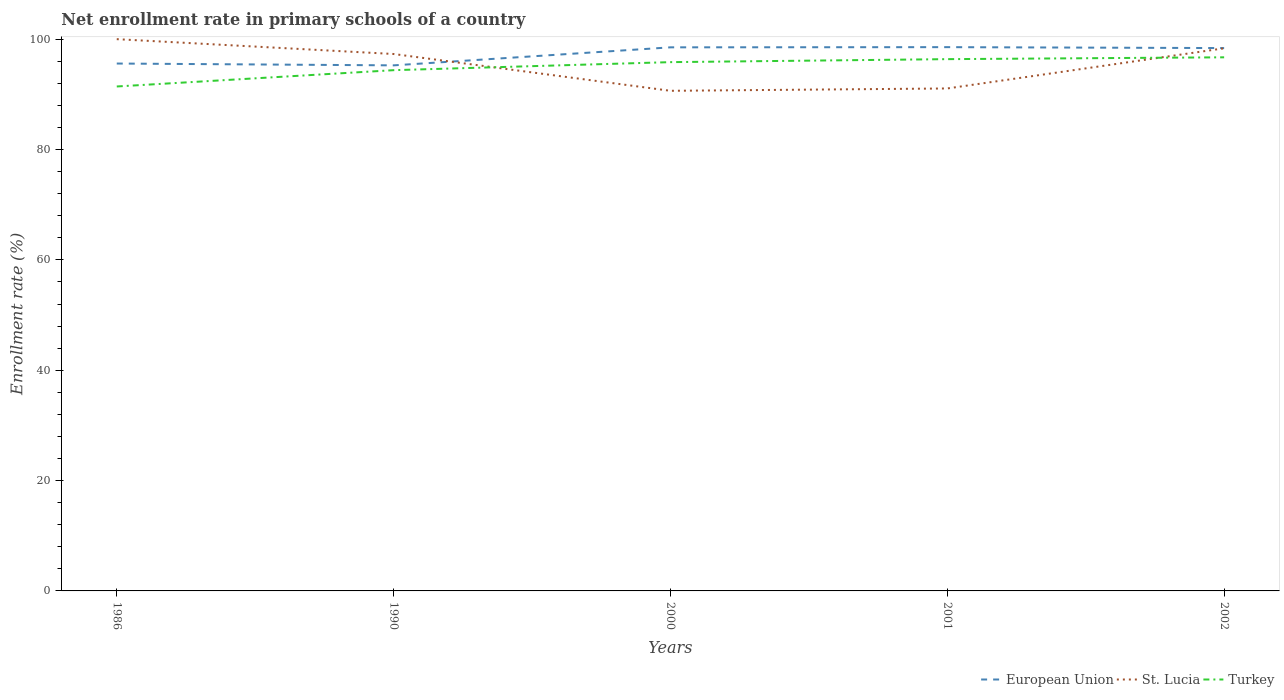Does the line corresponding to Turkey intersect with the line corresponding to St. Lucia?
Ensure brevity in your answer.  Yes. Is the number of lines equal to the number of legend labels?
Your answer should be compact. Yes. Across all years, what is the maximum enrollment rate in primary schools in European Union?
Give a very brief answer. 95.25. What is the total enrollment rate in primary schools in European Union in the graph?
Your answer should be compact. -2.8. What is the difference between the highest and the second highest enrollment rate in primary schools in Turkey?
Your response must be concise. 5.29. Is the enrollment rate in primary schools in St. Lucia strictly greater than the enrollment rate in primary schools in European Union over the years?
Give a very brief answer. No. How many years are there in the graph?
Provide a succinct answer. 5. What is the difference between two consecutive major ticks on the Y-axis?
Keep it short and to the point. 20. Does the graph contain any zero values?
Offer a terse response. No. Does the graph contain grids?
Ensure brevity in your answer.  No. How many legend labels are there?
Offer a terse response. 3. What is the title of the graph?
Give a very brief answer. Net enrollment rate in primary schools of a country. What is the label or title of the Y-axis?
Provide a short and direct response. Enrollment rate (%). What is the Enrollment rate (%) in European Union in 1986?
Give a very brief answer. 95.58. What is the Enrollment rate (%) in Turkey in 1986?
Offer a terse response. 91.42. What is the Enrollment rate (%) in European Union in 1990?
Ensure brevity in your answer.  95.25. What is the Enrollment rate (%) of St. Lucia in 1990?
Offer a terse response. 97.31. What is the Enrollment rate (%) of Turkey in 1990?
Provide a short and direct response. 94.38. What is the Enrollment rate (%) of European Union in 2000?
Keep it short and to the point. 98.52. What is the Enrollment rate (%) of St. Lucia in 2000?
Your answer should be very brief. 90.64. What is the Enrollment rate (%) in Turkey in 2000?
Give a very brief answer. 95.84. What is the Enrollment rate (%) of European Union in 2001?
Your answer should be compact. 98.55. What is the Enrollment rate (%) of St. Lucia in 2001?
Your answer should be very brief. 91.06. What is the Enrollment rate (%) in Turkey in 2001?
Ensure brevity in your answer.  96.38. What is the Enrollment rate (%) of European Union in 2002?
Provide a short and direct response. 98.38. What is the Enrollment rate (%) in St. Lucia in 2002?
Your answer should be compact. 98.34. What is the Enrollment rate (%) of Turkey in 2002?
Keep it short and to the point. 96.71. Across all years, what is the maximum Enrollment rate (%) of European Union?
Keep it short and to the point. 98.55. Across all years, what is the maximum Enrollment rate (%) in Turkey?
Keep it short and to the point. 96.71. Across all years, what is the minimum Enrollment rate (%) of European Union?
Provide a short and direct response. 95.25. Across all years, what is the minimum Enrollment rate (%) in St. Lucia?
Your response must be concise. 90.64. Across all years, what is the minimum Enrollment rate (%) of Turkey?
Offer a terse response. 91.42. What is the total Enrollment rate (%) of European Union in the graph?
Keep it short and to the point. 486.29. What is the total Enrollment rate (%) of St. Lucia in the graph?
Your answer should be very brief. 477.36. What is the total Enrollment rate (%) in Turkey in the graph?
Your answer should be very brief. 474.73. What is the difference between the Enrollment rate (%) of European Union in 1986 and that in 1990?
Give a very brief answer. 0.33. What is the difference between the Enrollment rate (%) in St. Lucia in 1986 and that in 1990?
Make the answer very short. 2.69. What is the difference between the Enrollment rate (%) in Turkey in 1986 and that in 1990?
Your answer should be compact. -2.95. What is the difference between the Enrollment rate (%) of European Union in 1986 and that in 2000?
Give a very brief answer. -2.94. What is the difference between the Enrollment rate (%) of St. Lucia in 1986 and that in 2000?
Your answer should be very brief. 9.36. What is the difference between the Enrollment rate (%) in Turkey in 1986 and that in 2000?
Your response must be concise. -4.41. What is the difference between the Enrollment rate (%) in European Union in 1986 and that in 2001?
Provide a succinct answer. -2.97. What is the difference between the Enrollment rate (%) in St. Lucia in 1986 and that in 2001?
Your answer should be compact. 8.94. What is the difference between the Enrollment rate (%) of Turkey in 1986 and that in 2001?
Offer a very short reply. -4.95. What is the difference between the Enrollment rate (%) of European Union in 1986 and that in 2002?
Keep it short and to the point. -2.8. What is the difference between the Enrollment rate (%) of St. Lucia in 1986 and that in 2002?
Ensure brevity in your answer.  1.66. What is the difference between the Enrollment rate (%) in Turkey in 1986 and that in 2002?
Offer a very short reply. -5.29. What is the difference between the Enrollment rate (%) in European Union in 1990 and that in 2000?
Keep it short and to the point. -3.27. What is the difference between the Enrollment rate (%) in St. Lucia in 1990 and that in 2000?
Ensure brevity in your answer.  6.67. What is the difference between the Enrollment rate (%) in Turkey in 1990 and that in 2000?
Offer a very short reply. -1.46. What is the difference between the Enrollment rate (%) of European Union in 1990 and that in 2001?
Give a very brief answer. -3.3. What is the difference between the Enrollment rate (%) of St. Lucia in 1990 and that in 2001?
Offer a very short reply. 6.24. What is the difference between the Enrollment rate (%) of Turkey in 1990 and that in 2001?
Ensure brevity in your answer.  -2. What is the difference between the Enrollment rate (%) in European Union in 1990 and that in 2002?
Provide a succinct answer. -3.13. What is the difference between the Enrollment rate (%) in St. Lucia in 1990 and that in 2002?
Offer a terse response. -1.03. What is the difference between the Enrollment rate (%) in Turkey in 1990 and that in 2002?
Your answer should be very brief. -2.33. What is the difference between the Enrollment rate (%) of European Union in 2000 and that in 2001?
Your answer should be very brief. -0.03. What is the difference between the Enrollment rate (%) in St. Lucia in 2000 and that in 2001?
Keep it short and to the point. -0.42. What is the difference between the Enrollment rate (%) of Turkey in 2000 and that in 2001?
Make the answer very short. -0.54. What is the difference between the Enrollment rate (%) of European Union in 2000 and that in 2002?
Make the answer very short. 0.13. What is the difference between the Enrollment rate (%) in St. Lucia in 2000 and that in 2002?
Your answer should be very brief. -7.7. What is the difference between the Enrollment rate (%) of Turkey in 2000 and that in 2002?
Keep it short and to the point. -0.87. What is the difference between the Enrollment rate (%) in European Union in 2001 and that in 2002?
Make the answer very short. 0.17. What is the difference between the Enrollment rate (%) of St. Lucia in 2001 and that in 2002?
Your answer should be very brief. -7.28. What is the difference between the Enrollment rate (%) of Turkey in 2001 and that in 2002?
Give a very brief answer. -0.33. What is the difference between the Enrollment rate (%) in European Union in 1986 and the Enrollment rate (%) in St. Lucia in 1990?
Provide a succinct answer. -1.73. What is the difference between the Enrollment rate (%) in European Union in 1986 and the Enrollment rate (%) in Turkey in 1990?
Keep it short and to the point. 1.2. What is the difference between the Enrollment rate (%) in St. Lucia in 1986 and the Enrollment rate (%) in Turkey in 1990?
Keep it short and to the point. 5.62. What is the difference between the Enrollment rate (%) in European Union in 1986 and the Enrollment rate (%) in St. Lucia in 2000?
Provide a succinct answer. 4.94. What is the difference between the Enrollment rate (%) of European Union in 1986 and the Enrollment rate (%) of Turkey in 2000?
Provide a succinct answer. -0.25. What is the difference between the Enrollment rate (%) of St. Lucia in 1986 and the Enrollment rate (%) of Turkey in 2000?
Ensure brevity in your answer.  4.16. What is the difference between the Enrollment rate (%) of European Union in 1986 and the Enrollment rate (%) of St. Lucia in 2001?
Your response must be concise. 4.52. What is the difference between the Enrollment rate (%) of European Union in 1986 and the Enrollment rate (%) of Turkey in 2001?
Provide a short and direct response. -0.8. What is the difference between the Enrollment rate (%) in St. Lucia in 1986 and the Enrollment rate (%) in Turkey in 2001?
Your response must be concise. 3.62. What is the difference between the Enrollment rate (%) of European Union in 1986 and the Enrollment rate (%) of St. Lucia in 2002?
Offer a terse response. -2.76. What is the difference between the Enrollment rate (%) of European Union in 1986 and the Enrollment rate (%) of Turkey in 2002?
Make the answer very short. -1.13. What is the difference between the Enrollment rate (%) of St. Lucia in 1986 and the Enrollment rate (%) of Turkey in 2002?
Offer a very short reply. 3.29. What is the difference between the Enrollment rate (%) of European Union in 1990 and the Enrollment rate (%) of St. Lucia in 2000?
Provide a short and direct response. 4.61. What is the difference between the Enrollment rate (%) of European Union in 1990 and the Enrollment rate (%) of Turkey in 2000?
Offer a very short reply. -0.58. What is the difference between the Enrollment rate (%) of St. Lucia in 1990 and the Enrollment rate (%) of Turkey in 2000?
Keep it short and to the point. 1.47. What is the difference between the Enrollment rate (%) in European Union in 1990 and the Enrollment rate (%) in St. Lucia in 2001?
Ensure brevity in your answer.  4.19. What is the difference between the Enrollment rate (%) in European Union in 1990 and the Enrollment rate (%) in Turkey in 2001?
Keep it short and to the point. -1.13. What is the difference between the Enrollment rate (%) in St. Lucia in 1990 and the Enrollment rate (%) in Turkey in 2001?
Offer a terse response. 0.93. What is the difference between the Enrollment rate (%) of European Union in 1990 and the Enrollment rate (%) of St. Lucia in 2002?
Offer a terse response. -3.09. What is the difference between the Enrollment rate (%) in European Union in 1990 and the Enrollment rate (%) in Turkey in 2002?
Ensure brevity in your answer.  -1.46. What is the difference between the Enrollment rate (%) in St. Lucia in 1990 and the Enrollment rate (%) in Turkey in 2002?
Give a very brief answer. 0.6. What is the difference between the Enrollment rate (%) of European Union in 2000 and the Enrollment rate (%) of St. Lucia in 2001?
Your response must be concise. 7.45. What is the difference between the Enrollment rate (%) in European Union in 2000 and the Enrollment rate (%) in Turkey in 2001?
Offer a very short reply. 2.14. What is the difference between the Enrollment rate (%) of St. Lucia in 2000 and the Enrollment rate (%) of Turkey in 2001?
Offer a terse response. -5.74. What is the difference between the Enrollment rate (%) in European Union in 2000 and the Enrollment rate (%) in St. Lucia in 2002?
Provide a short and direct response. 0.17. What is the difference between the Enrollment rate (%) in European Union in 2000 and the Enrollment rate (%) in Turkey in 2002?
Keep it short and to the point. 1.81. What is the difference between the Enrollment rate (%) of St. Lucia in 2000 and the Enrollment rate (%) of Turkey in 2002?
Keep it short and to the point. -6.07. What is the difference between the Enrollment rate (%) of European Union in 2001 and the Enrollment rate (%) of St. Lucia in 2002?
Give a very brief answer. 0.21. What is the difference between the Enrollment rate (%) in European Union in 2001 and the Enrollment rate (%) in Turkey in 2002?
Provide a short and direct response. 1.84. What is the difference between the Enrollment rate (%) of St. Lucia in 2001 and the Enrollment rate (%) of Turkey in 2002?
Your answer should be very brief. -5.65. What is the average Enrollment rate (%) of European Union per year?
Provide a short and direct response. 97.26. What is the average Enrollment rate (%) in St. Lucia per year?
Ensure brevity in your answer.  95.47. What is the average Enrollment rate (%) of Turkey per year?
Your answer should be compact. 94.95. In the year 1986, what is the difference between the Enrollment rate (%) in European Union and Enrollment rate (%) in St. Lucia?
Provide a short and direct response. -4.42. In the year 1986, what is the difference between the Enrollment rate (%) in European Union and Enrollment rate (%) in Turkey?
Offer a terse response. 4.16. In the year 1986, what is the difference between the Enrollment rate (%) in St. Lucia and Enrollment rate (%) in Turkey?
Make the answer very short. 8.58. In the year 1990, what is the difference between the Enrollment rate (%) in European Union and Enrollment rate (%) in St. Lucia?
Your response must be concise. -2.06. In the year 1990, what is the difference between the Enrollment rate (%) in European Union and Enrollment rate (%) in Turkey?
Give a very brief answer. 0.87. In the year 1990, what is the difference between the Enrollment rate (%) of St. Lucia and Enrollment rate (%) of Turkey?
Offer a terse response. 2.93. In the year 2000, what is the difference between the Enrollment rate (%) of European Union and Enrollment rate (%) of St. Lucia?
Your answer should be compact. 7.88. In the year 2000, what is the difference between the Enrollment rate (%) of European Union and Enrollment rate (%) of Turkey?
Give a very brief answer. 2.68. In the year 2000, what is the difference between the Enrollment rate (%) in St. Lucia and Enrollment rate (%) in Turkey?
Make the answer very short. -5.2. In the year 2001, what is the difference between the Enrollment rate (%) of European Union and Enrollment rate (%) of St. Lucia?
Offer a terse response. 7.49. In the year 2001, what is the difference between the Enrollment rate (%) of European Union and Enrollment rate (%) of Turkey?
Give a very brief answer. 2.17. In the year 2001, what is the difference between the Enrollment rate (%) of St. Lucia and Enrollment rate (%) of Turkey?
Your answer should be compact. -5.31. In the year 2002, what is the difference between the Enrollment rate (%) of European Union and Enrollment rate (%) of St. Lucia?
Offer a very short reply. 0.04. In the year 2002, what is the difference between the Enrollment rate (%) in European Union and Enrollment rate (%) in Turkey?
Offer a terse response. 1.67. In the year 2002, what is the difference between the Enrollment rate (%) in St. Lucia and Enrollment rate (%) in Turkey?
Provide a succinct answer. 1.63. What is the ratio of the Enrollment rate (%) of St. Lucia in 1986 to that in 1990?
Make the answer very short. 1.03. What is the ratio of the Enrollment rate (%) in Turkey in 1986 to that in 1990?
Offer a terse response. 0.97. What is the ratio of the Enrollment rate (%) in European Union in 1986 to that in 2000?
Keep it short and to the point. 0.97. What is the ratio of the Enrollment rate (%) in St. Lucia in 1986 to that in 2000?
Give a very brief answer. 1.1. What is the ratio of the Enrollment rate (%) in Turkey in 1986 to that in 2000?
Give a very brief answer. 0.95. What is the ratio of the Enrollment rate (%) in European Union in 1986 to that in 2001?
Offer a very short reply. 0.97. What is the ratio of the Enrollment rate (%) of St. Lucia in 1986 to that in 2001?
Offer a terse response. 1.1. What is the ratio of the Enrollment rate (%) of Turkey in 1986 to that in 2001?
Offer a terse response. 0.95. What is the ratio of the Enrollment rate (%) in European Union in 1986 to that in 2002?
Offer a very short reply. 0.97. What is the ratio of the Enrollment rate (%) of St. Lucia in 1986 to that in 2002?
Make the answer very short. 1.02. What is the ratio of the Enrollment rate (%) in Turkey in 1986 to that in 2002?
Your answer should be compact. 0.95. What is the ratio of the Enrollment rate (%) of European Union in 1990 to that in 2000?
Keep it short and to the point. 0.97. What is the ratio of the Enrollment rate (%) of St. Lucia in 1990 to that in 2000?
Provide a short and direct response. 1.07. What is the ratio of the Enrollment rate (%) of Turkey in 1990 to that in 2000?
Your response must be concise. 0.98. What is the ratio of the Enrollment rate (%) of European Union in 1990 to that in 2001?
Your answer should be compact. 0.97. What is the ratio of the Enrollment rate (%) in St. Lucia in 1990 to that in 2001?
Keep it short and to the point. 1.07. What is the ratio of the Enrollment rate (%) of Turkey in 1990 to that in 2001?
Ensure brevity in your answer.  0.98. What is the ratio of the Enrollment rate (%) in European Union in 1990 to that in 2002?
Give a very brief answer. 0.97. What is the ratio of the Enrollment rate (%) of Turkey in 1990 to that in 2002?
Ensure brevity in your answer.  0.98. What is the ratio of the Enrollment rate (%) of European Union in 2000 to that in 2001?
Offer a very short reply. 1. What is the ratio of the Enrollment rate (%) of St. Lucia in 2000 to that in 2001?
Your answer should be very brief. 1. What is the ratio of the Enrollment rate (%) in St. Lucia in 2000 to that in 2002?
Provide a short and direct response. 0.92. What is the ratio of the Enrollment rate (%) of Turkey in 2000 to that in 2002?
Offer a terse response. 0.99. What is the ratio of the Enrollment rate (%) of European Union in 2001 to that in 2002?
Your answer should be very brief. 1. What is the ratio of the Enrollment rate (%) in St. Lucia in 2001 to that in 2002?
Provide a succinct answer. 0.93. What is the ratio of the Enrollment rate (%) in Turkey in 2001 to that in 2002?
Your response must be concise. 1. What is the difference between the highest and the second highest Enrollment rate (%) of European Union?
Your answer should be compact. 0.03. What is the difference between the highest and the second highest Enrollment rate (%) of St. Lucia?
Offer a very short reply. 1.66. What is the difference between the highest and the second highest Enrollment rate (%) of Turkey?
Make the answer very short. 0.33. What is the difference between the highest and the lowest Enrollment rate (%) in European Union?
Ensure brevity in your answer.  3.3. What is the difference between the highest and the lowest Enrollment rate (%) in St. Lucia?
Your response must be concise. 9.36. What is the difference between the highest and the lowest Enrollment rate (%) in Turkey?
Ensure brevity in your answer.  5.29. 